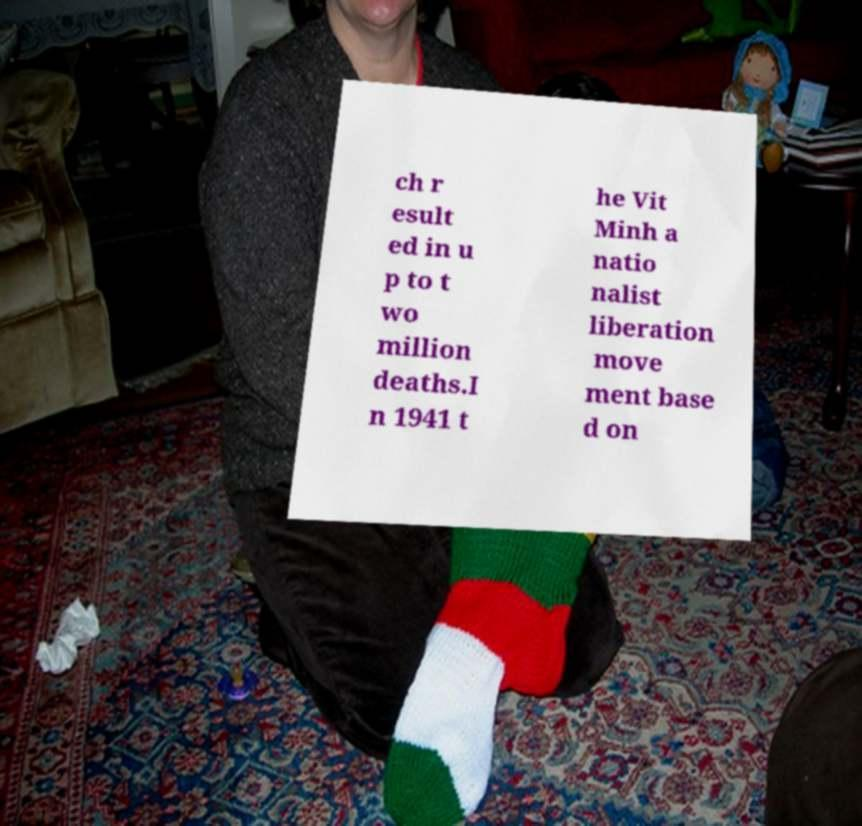Could you extract and type out the text from this image? ch r esult ed in u p to t wo million deaths.I n 1941 t he Vit Minh a natio nalist liberation move ment base d on 